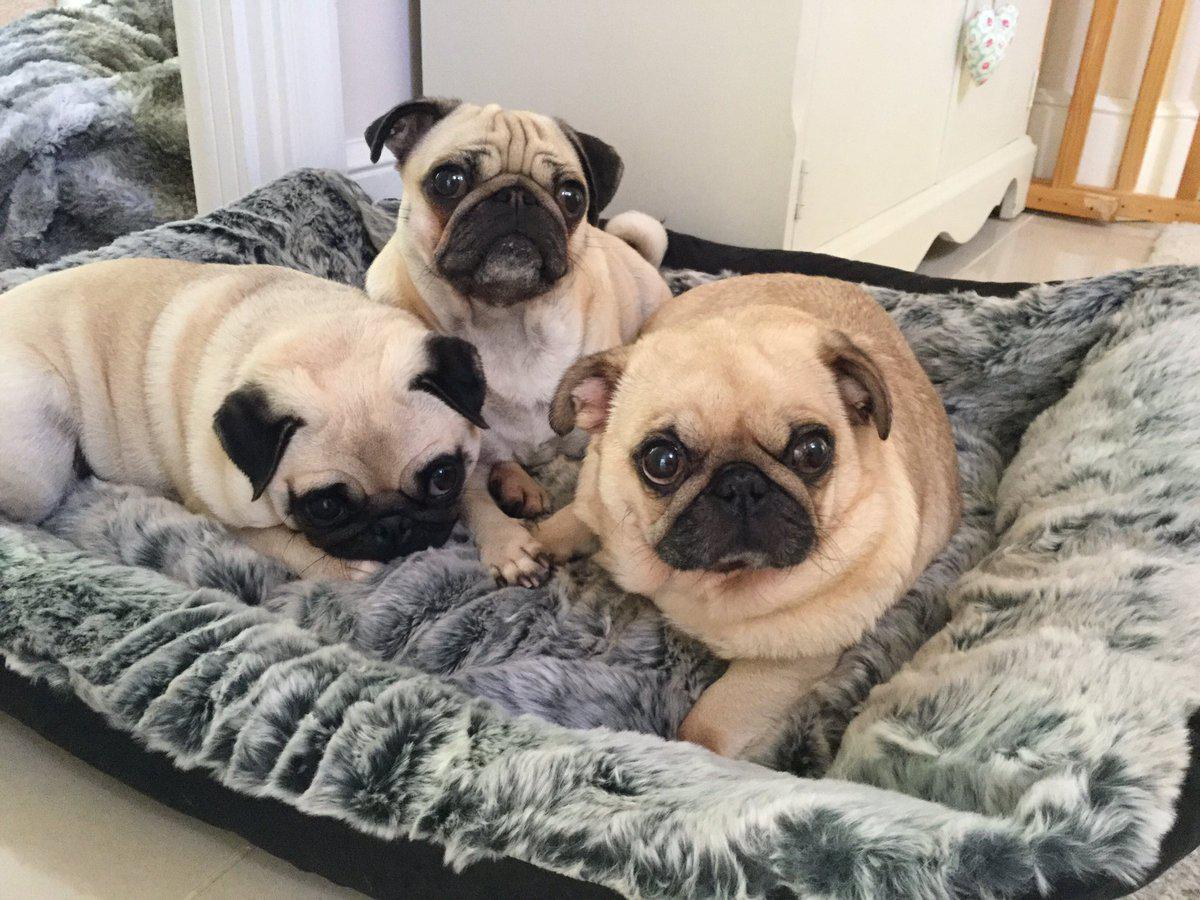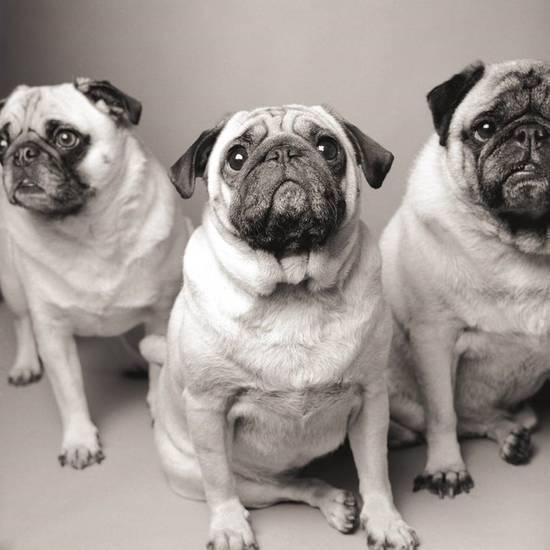The first image is the image on the left, the second image is the image on the right. Analyze the images presented: Is the assertion "There are exactly three dogs in the right image." valid? Answer yes or no. Yes. The first image is the image on the left, the second image is the image on the right. Analyze the images presented: Is the assertion "An image features three pugs in costumes that include fur trimming." valid? Answer yes or no. No. 